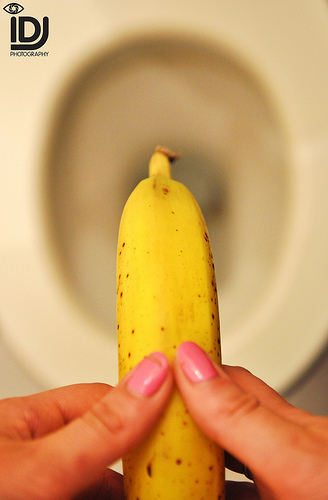<image>
Can you confirm if the banana is in front of the nail? No. The banana is not in front of the nail. The spatial positioning shows a different relationship between these objects. 